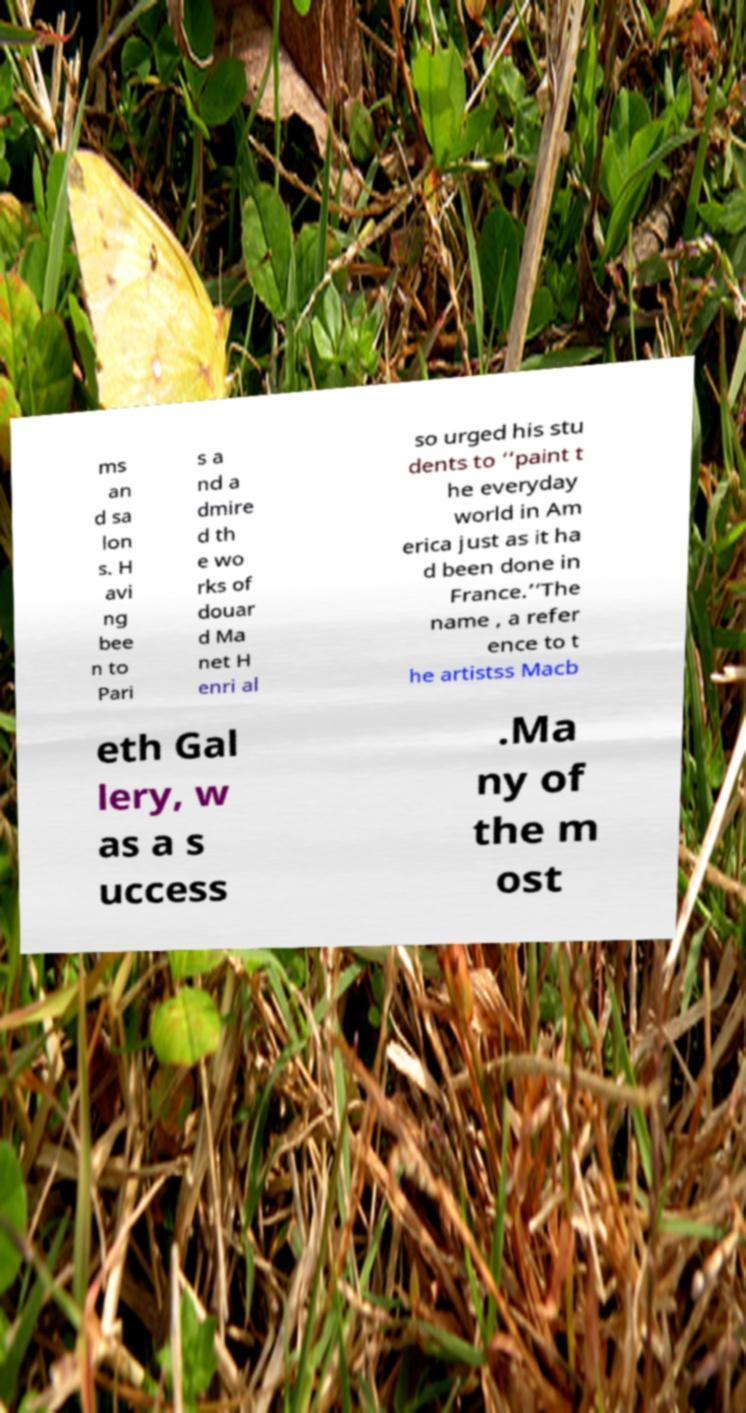I need the written content from this picture converted into text. Can you do that? ms an d sa lon s. H avi ng bee n to Pari s a nd a dmire d th e wo rks of douar d Ma net H enri al so urged his stu dents to ‘’paint t he everyday world in Am erica just as it ha d been done in France.’’The name , a refer ence to t he artistss Macb eth Gal lery, w as a s uccess .Ma ny of the m ost 